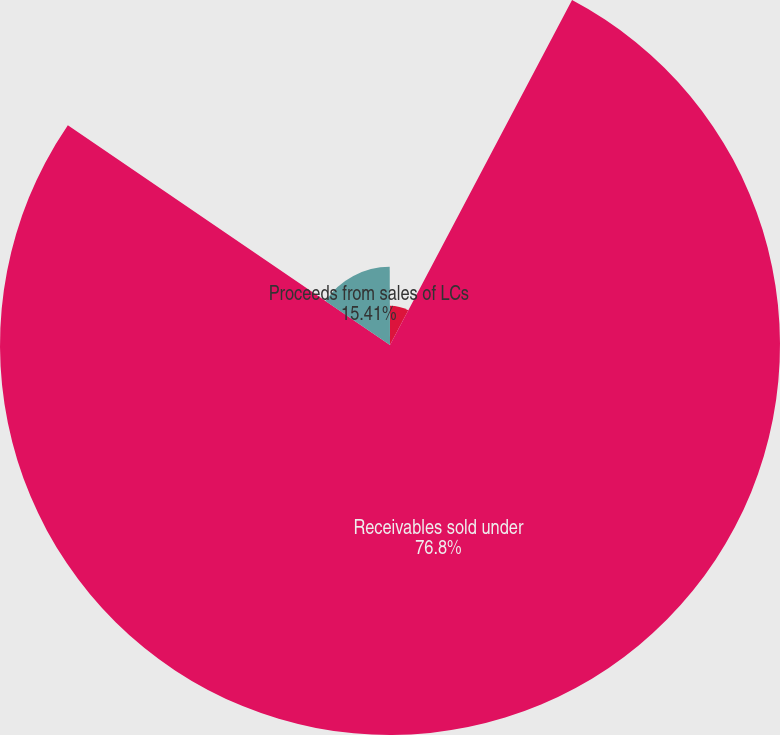Convert chart. <chart><loc_0><loc_0><loc_500><loc_500><pie_chart><fcel>(In thousands)<fcel>Receivables sold under<fcel>Proceeds from sales of LCs<fcel>Discounting fees paid on sales<nl><fcel>7.73%<fcel>76.8%<fcel>15.41%<fcel>0.06%<nl></chart> 